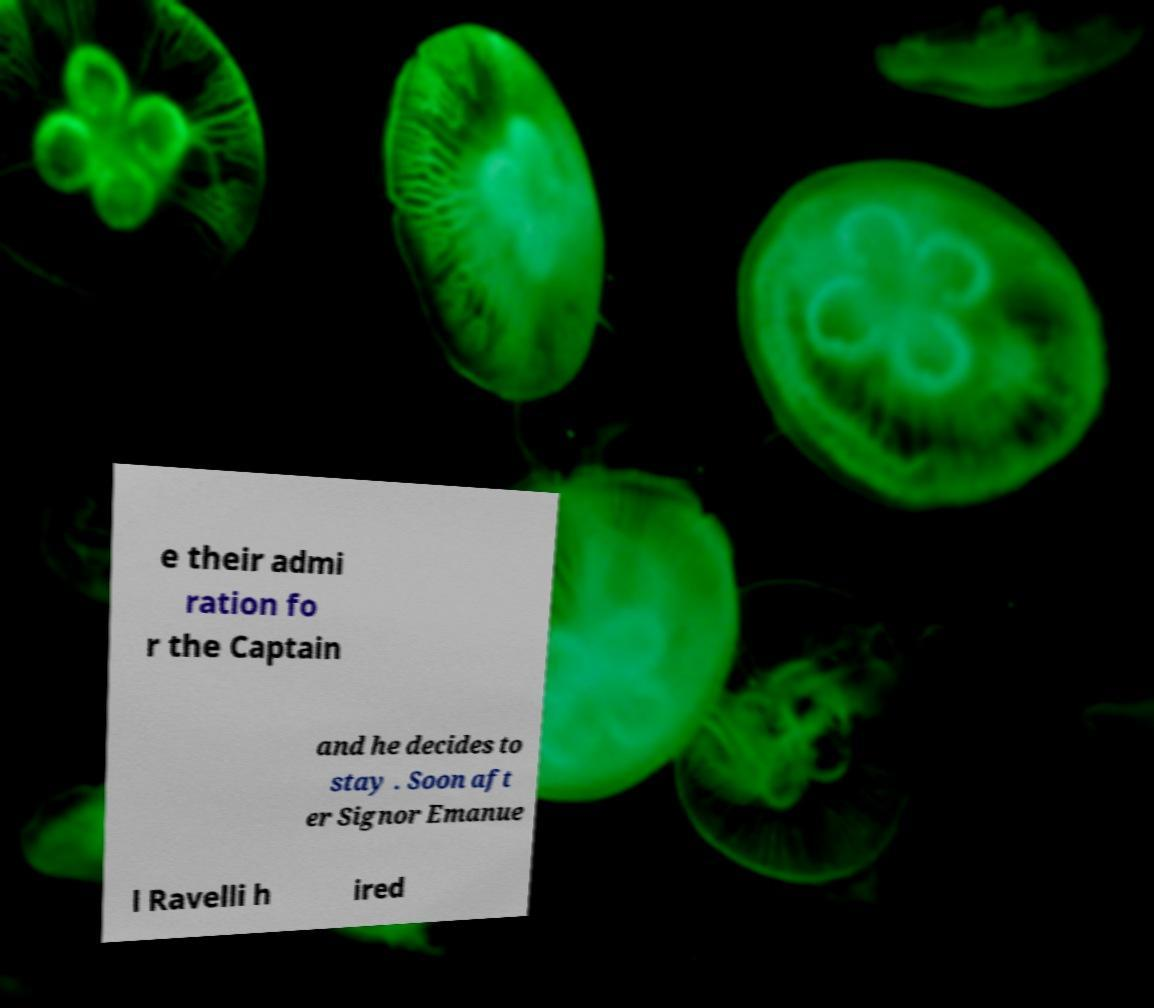Please read and relay the text visible in this image. What does it say? e their admi ration fo r the Captain and he decides to stay . Soon aft er Signor Emanue l Ravelli h ired 